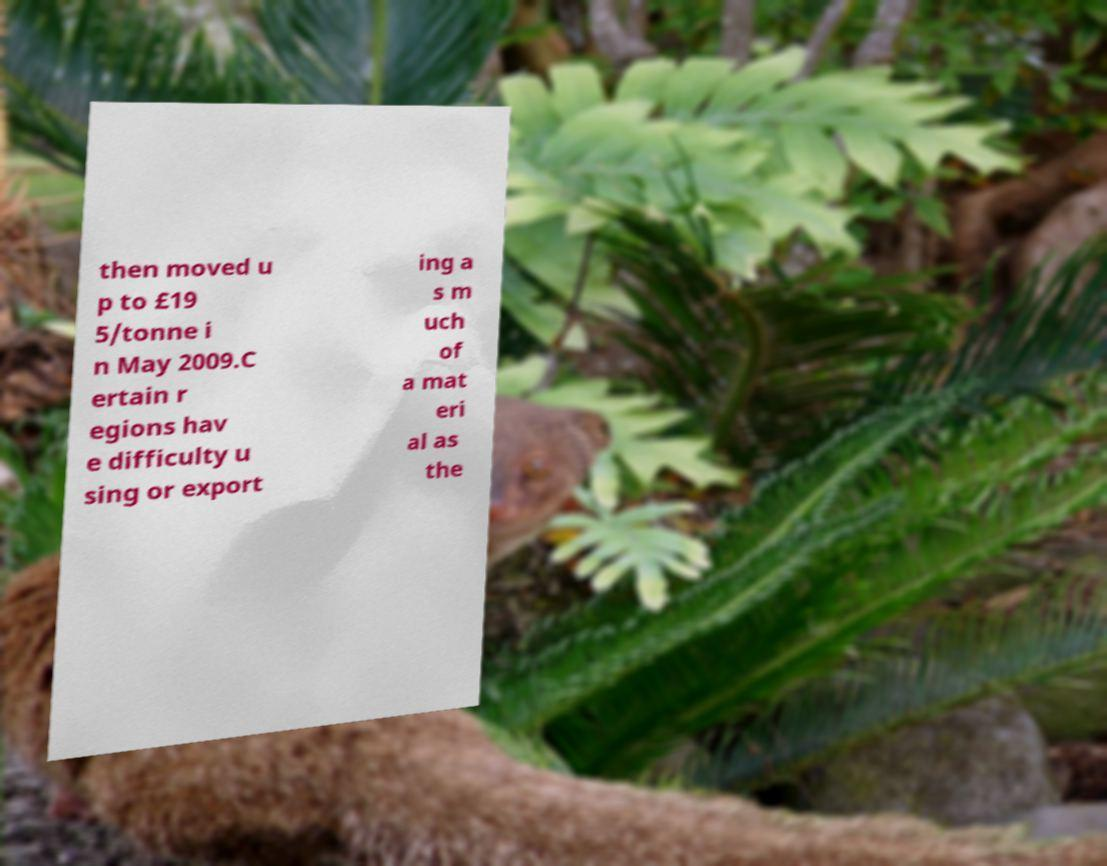Please identify and transcribe the text found in this image. then moved u p to £19 5/tonne i n May 2009.C ertain r egions hav e difficulty u sing or export ing a s m uch of a mat eri al as the 